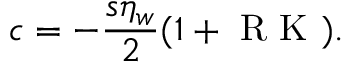<formula> <loc_0><loc_0><loc_500><loc_500>c = - \frac { s \eta _ { w } } { 2 } ( 1 + R K ) .</formula> 